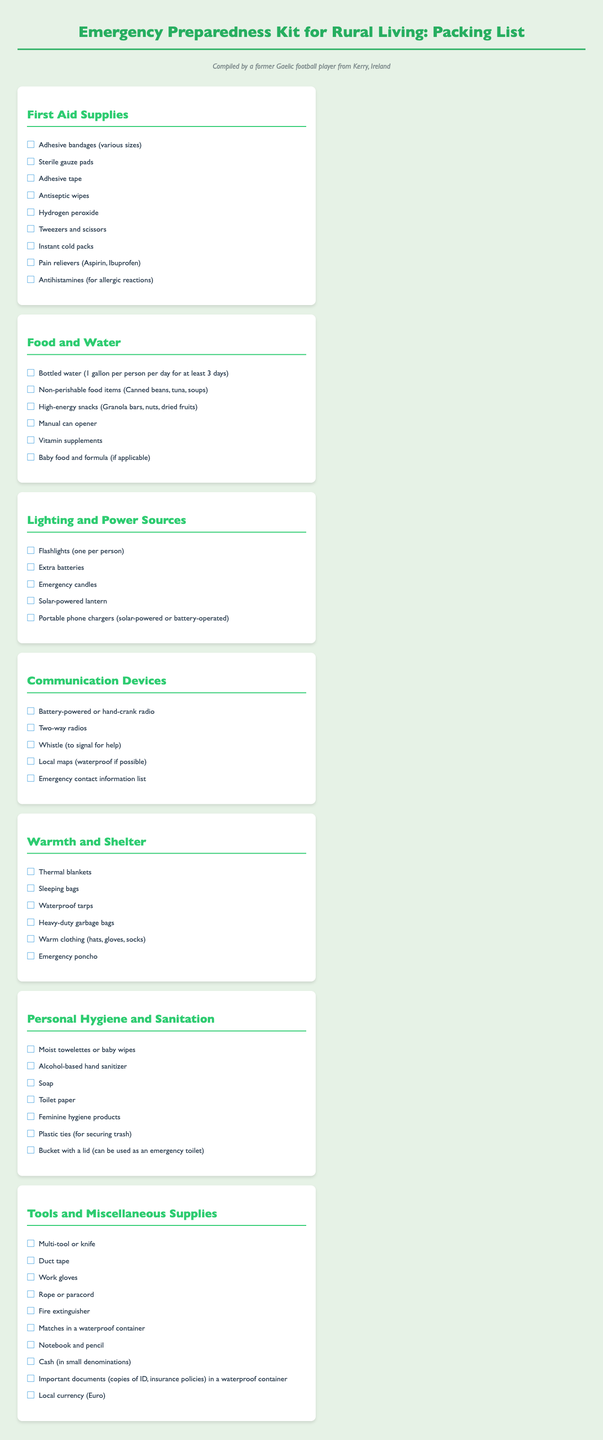What is the first item listed under First Aid Supplies? The first item listed in the First Aid Supplies section is the Adhesive bandages.
Answer: Adhesive bandages How many gallons of bottled water should be stored per person for three days? The document states that one gallon per person per day should be stored for at least three days, totaling three gallons per person.
Answer: 3 gallons What type of radio is included in the Communication Devices section? The document specifies a battery-powered or hand-crank radio in the Communication Devices section.
Answer: Battery-powered or hand-crank radio What is included in the Warmth and Shelter section? The Warmth and Shelter section includes various items such as thermal blankets, sleeping bags, and waterproof tarps.
Answer: Thermal blankets, sleeping bags, waterproof tarps What personal hygiene item is mentioned for cleaning hands? The document lists alcohol-based hand sanitizer as a personal hygiene item for cleaning hands.
Answer: Alcohol-based hand sanitizer Which tool is mentioned for securing trash in the Personal Hygiene and Sanitation section? The document states that plastic ties can be used for securing trash in that section.
Answer: Plastic ties How many items are listed under Tools and Miscellaneous Supplies? There are nine items listed in the Tools and Miscellaneous Supplies section.
Answer: 9 items What type of charger is recommended in the Lighting and Power Sources section? The document suggests using portable phone chargers, which can be solar-powered or battery-operated.
Answer: Portable phone chargers Which non-perishable food item is suggested that is high in energy? The document recommends granola bars as a high-energy snack.
Answer: Granola bars 